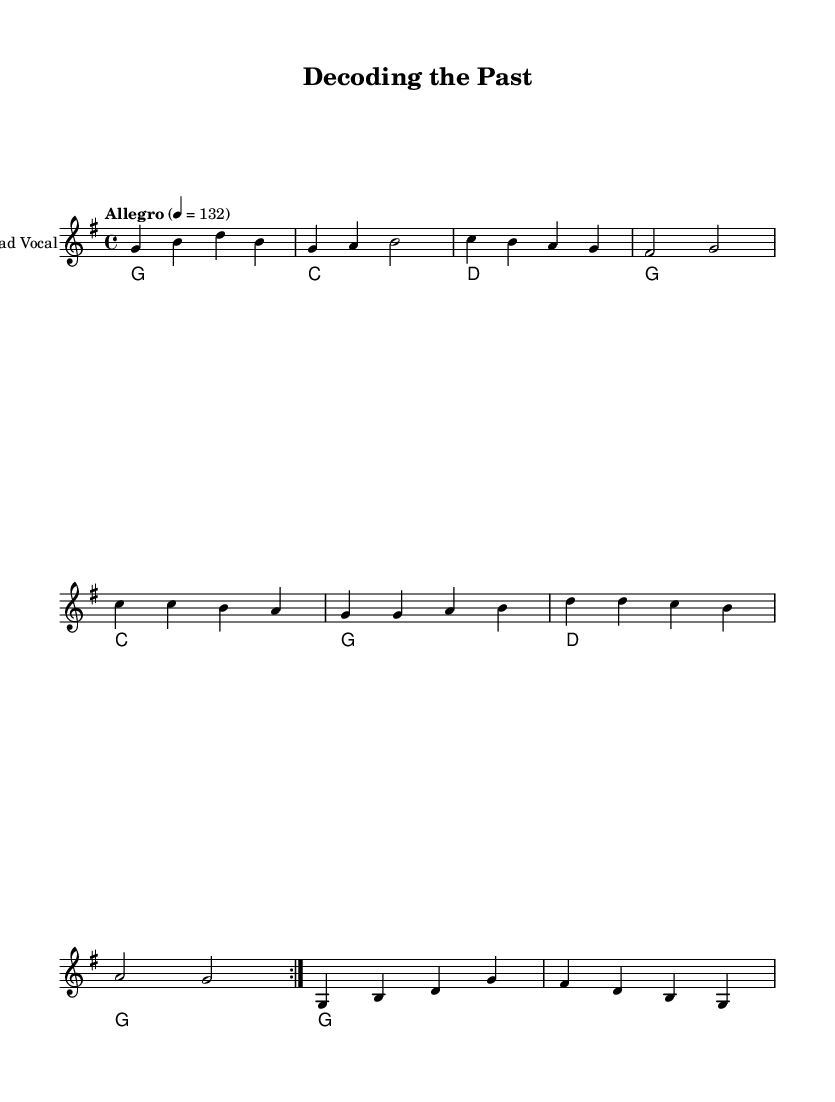What is the key signature of this music? The key signature is G major, which has one sharp (F#). We can determine this by looking at the initial part of the score where the key is indicated.
Answer: G major What is the time signature of this music? The time signature is 4/4, which shows that there are four beats in each measure. This is indicated at the beginning of the score.
Answer: 4/4 What is the tempo marking in this music? The tempo marking is "Allegro," which typically indicates a fast and lively tempo. This is conveyed at the start of the score, along with the note value.
Answer: Allegro How many measures are in the verse section? The verse section consists of 4 measures, which can be counted in the score where the verses are written. The verse is laid out clearly and has 4 separate time signatures indicating individual counting for each measure.
Answer: 4 How many times is the chorus repeated? The chorus is repeated 2 times as indicated by the "repeat volta 2" notation in the score. This notation directs musicians to perform the chorus twice before moving on.
Answer: 2 What instrument is indicated for the lead vocal? The instrument's name is "Lead Vocal," as specified in the staff section of the score. Musicians can identify it at the beginning of the vocal line.
Answer: Lead Vocal What is the main thematic focus in the lyrics of this song? The lyrics highlight the theme of "decoding the past," which indicates a focus on linguistics and technological breakthroughs. This thematic statement is reinforced by the words visible in the lyrics section.
Answer: Decoding the past 